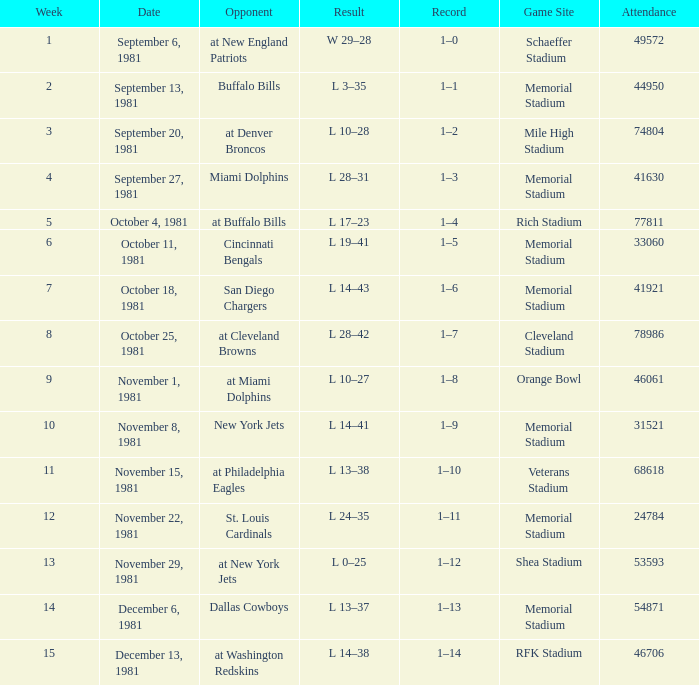When it is October 25, 1981 who is the opponent? At cleveland browns. Can you give me this table as a dict? {'header': ['Week', 'Date', 'Opponent', 'Result', 'Record', 'Game Site', 'Attendance'], 'rows': [['1', 'September 6, 1981', 'at New England Patriots', 'W 29–28', '1–0', 'Schaeffer Stadium', '49572'], ['2', 'September 13, 1981', 'Buffalo Bills', 'L 3–35', '1–1', 'Memorial Stadium', '44950'], ['3', 'September 20, 1981', 'at Denver Broncos', 'L 10–28', '1–2', 'Mile High Stadium', '74804'], ['4', 'September 27, 1981', 'Miami Dolphins', 'L 28–31', '1–3', 'Memorial Stadium', '41630'], ['5', 'October 4, 1981', 'at Buffalo Bills', 'L 17–23', '1–4', 'Rich Stadium', '77811'], ['6', 'October 11, 1981', 'Cincinnati Bengals', 'L 19–41', '1–5', 'Memorial Stadium', '33060'], ['7', 'October 18, 1981', 'San Diego Chargers', 'L 14–43', '1–6', 'Memorial Stadium', '41921'], ['8', 'October 25, 1981', 'at Cleveland Browns', 'L 28–42', '1–7', 'Cleveland Stadium', '78986'], ['9', 'November 1, 1981', 'at Miami Dolphins', 'L 10–27', '1–8', 'Orange Bowl', '46061'], ['10', 'November 8, 1981', 'New York Jets', 'L 14–41', '1–9', 'Memorial Stadium', '31521'], ['11', 'November 15, 1981', 'at Philadelphia Eagles', 'L 13–38', '1–10', 'Veterans Stadium', '68618'], ['12', 'November 22, 1981', 'St. Louis Cardinals', 'L 24–35', '1–11', 'Memorial Stadium', '24784'], ['13', 'November 29, 1981', 'at New York Jets', 'L 0–25', '1–12', 'Shea Stadium', '53593'], ['14', 'December 6, 1981', 'Dallas Cowboys', 'L 13–37', '1–13', 'Memorial Stadium', '54871'], ['15', 'December 13, 1981', 'at Washington Redskins', 'L 14–38', '1–14', 'RFK Stadium', '46706']]} 